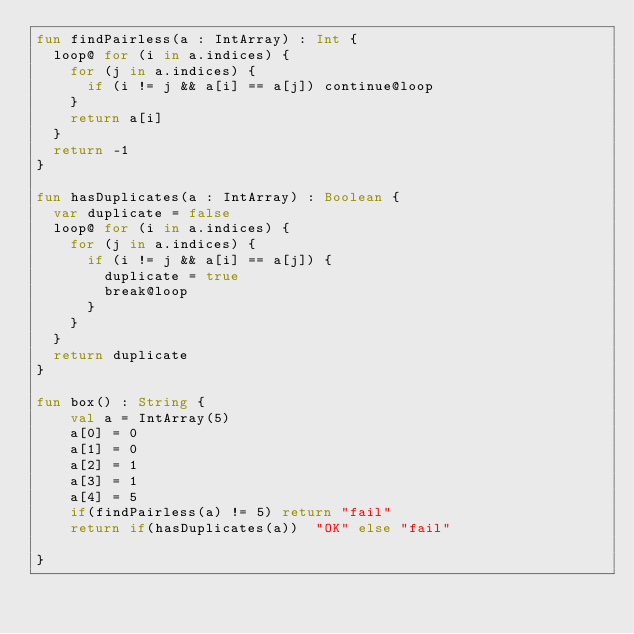<code> <loc_0><loc_0><loc_500><loc_500><_Kotlin_>fun findPairless(a : IntArray) : Int {
  loop@ for (i in a.indices) {
    for (j in a.indices) {
      if (i != j && a[i] == a[j]) continue@loop
    }
    return a[i]
  }
  return -1
}

fun hasDuplicates(a : IntArray) : Boolean {
  var duplicate = false
  loop@ for (i in a.indices) {
    for (j in a.indices) {
      if (i != j && a[i] == a[j]) {
        duplicate = true
        break@loop
      }
    }
  }
  return duplicate
}

fun box() : String {
    val a = IntArray(5)
    a[0] = 0
    a[1] = 0
    a[2] = 1
    a[3] = 1
    a[4] = 5
    if(findPairless(a) != 5) return "fail"
    return if(hasDuplicates(a))  "OK" else "fail"

}
</code> 